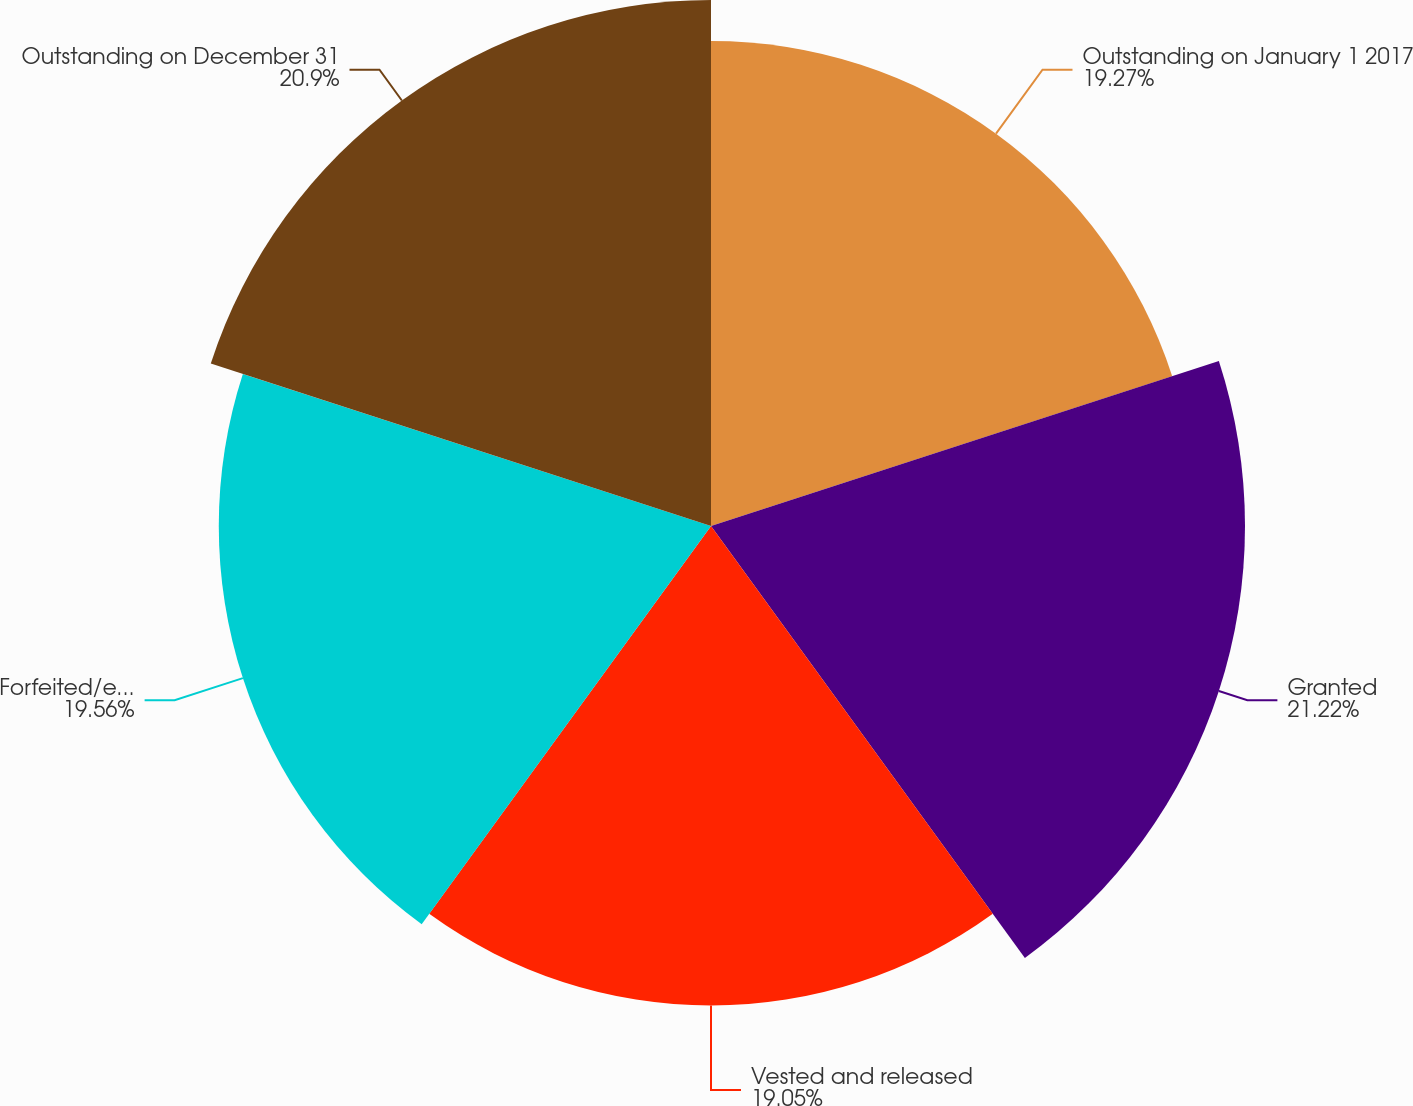Convert chart to OTSL. <chart><loc_0><loc_0><loc_500><loc_500><pie_chart><fcel>Outstanding on January 1 2017<fcel>Granted<fcel>Vested and released<fcel>Forfeited/expired<fcel>Outstanding on December 31<nl><fcel>19.27%<fcel>21.22%<fcel>19.05%<fcel>19.56%<fcel>20.9%<nl></chart> 